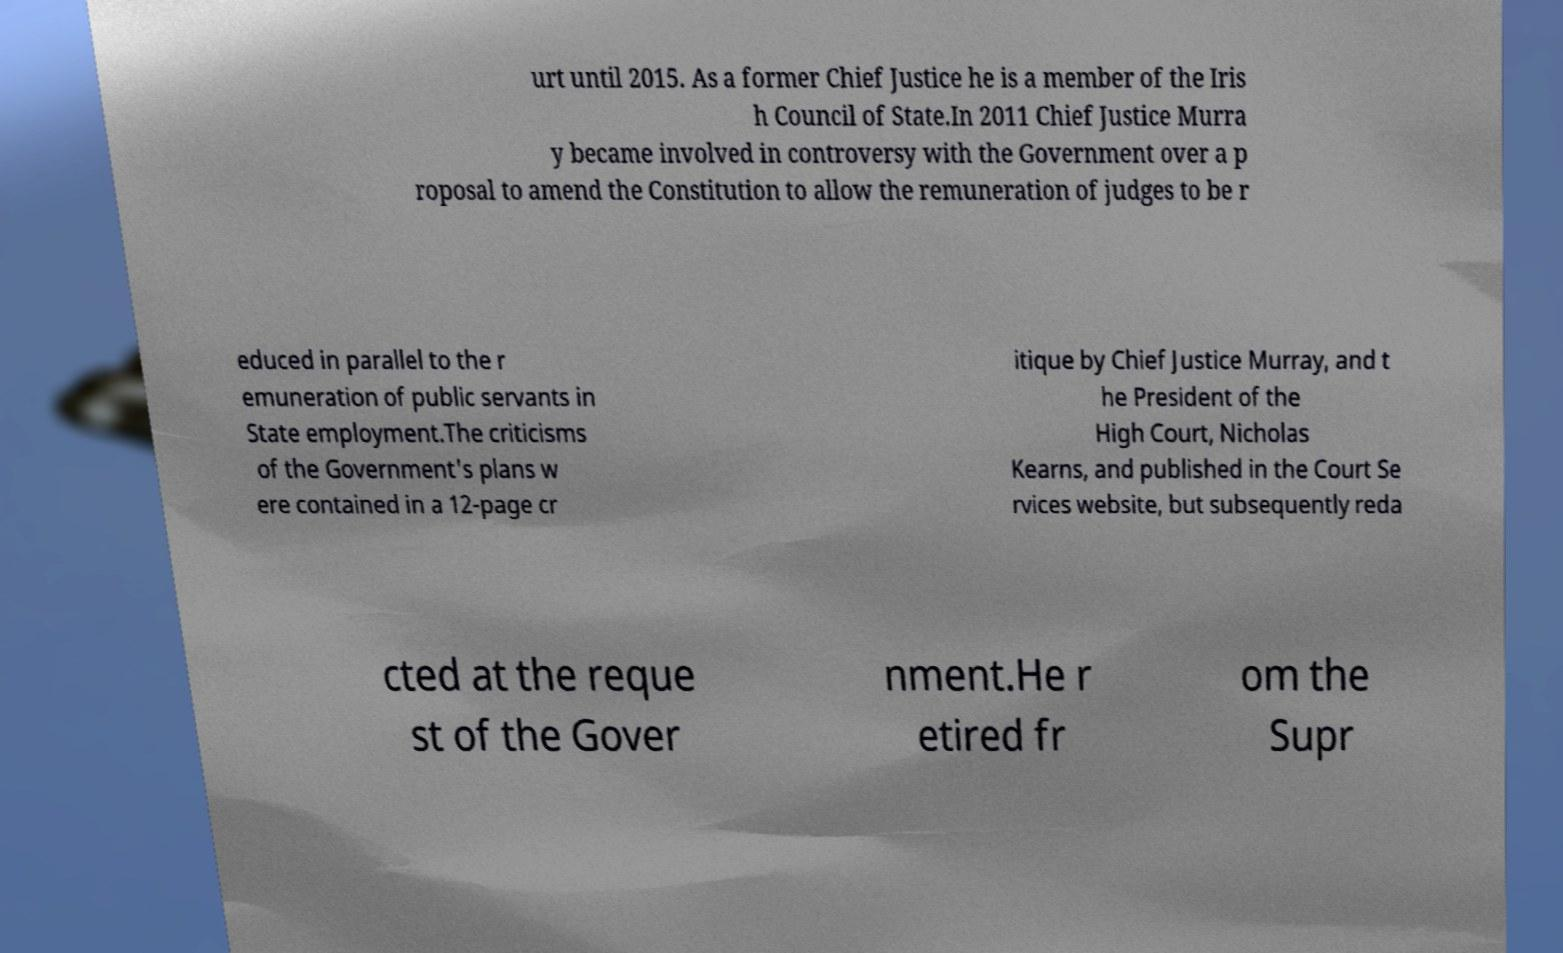Could you assist in decoding the text presented in this image and type it out clearly? urt until 2015. As a former Chief Justice he is a member of the Iris h Council of State.In 2011 Chief Justice Murra y became involved in controversy with the Government over a p roposal to amend the Constitution to allow the remuneration of judges to be r educed in parallel to the r emuneration of public servants in State employment.The criticisms of the Government's plans w ere contained in a 12-page cr itique by Chief Justice Murray, and t he President of the High Court, Nicholas Kearns, and published in the Court Se rvices website, but subsequently reda cted at the reque st of the Gover nment.He r etired fr om the Supr 